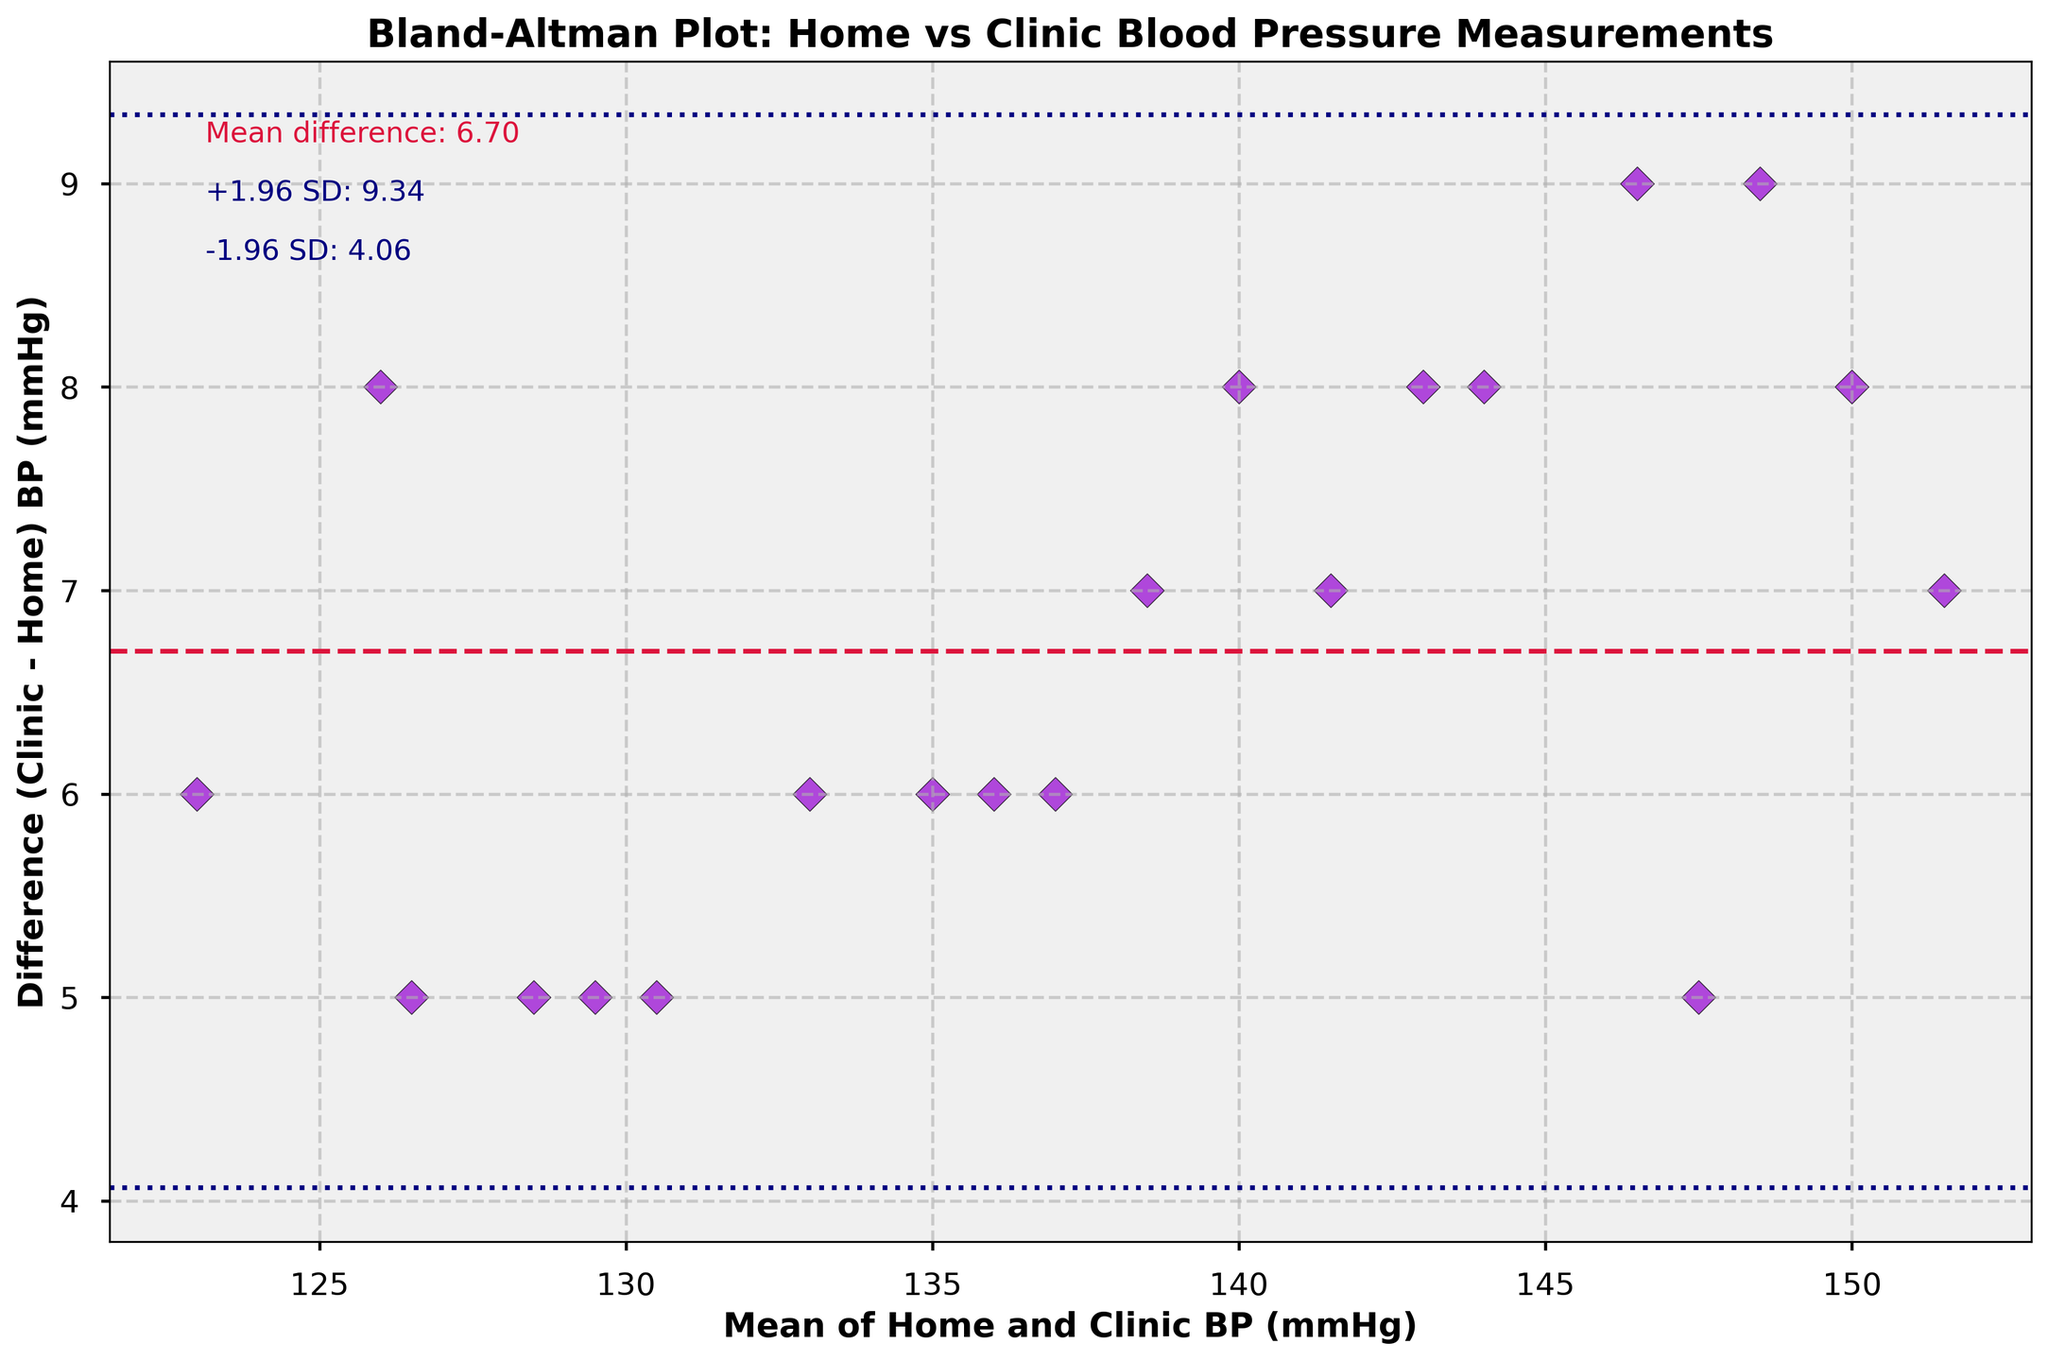What is the title of this plot? The title of the plot is displayed at the top and it indicates what the plot is about. In this case, it reads "Bland-Altman Plot: Home vs Clinic Blood Pressure Measurements".
Answer: Bland-Altman Plot: Home vs Clinic Blood Pressure Measurements How many data points are plotted in the figure? Count each marker (diamond) in the plot to determine the total number of data points. There are 20 markers.
Answer: 20 What does the x-axis represent in this plot? The x-axis label indicates it represents the "Mean of Home and Clinic BP (mmHg)", which is the average of the home and clinic blood pressure readings for each data point.
Answer: Mean of Home and Clinic BP (mmHg) What color and shape are the data points in the plot? Each data point is colored dark violet. They are diamond-shaped and outlined in black.
Answer: Dark violet diamonds outlined in black What is the mean difference between clinic and home measurements? The mean difference (or "md") is annotated on the plot. It is the value where the horizontal crimson dashed line is placed and noted as "Mean difference: 6.65".
Answer: 6.65 mmHg What is the approximate value of the upper limit of agreement? The upper limit of agreement is the mean difference plus 1.96 times the standard deviation, which is annotated as "+1.96 SD: 8.90" on the plot.
Answer: 8.90 mmHg What does the horizontal crimson dashed line represent? The horizontal crimson dashed line represents the mean difference between clinic and home measurements, visually indicated on the plot at the value 6.65 mmHg.
Answer: Mean difference between clinic and home measurements Are most of the differences positive or negative? By observing the position of most of the data points relative to the mean difference line, we can see that the majority of the points lie above the horizontal crimson dashed line, meaning the differences are mostly positive.
Answer: Positive How many data points exceed the upper limit of agreement? Count the number of points above the upper dashed navy line, which corresponds to the "+1.96 SD" limit. There are no data points above this line.
Answer: 0 What is the significance of the dashed navy lines? The dashed navy lines represent the limits of agreement, set at ±1.96 standard deviations from the mean difference. These lines encompass most of the data and indicate where most differences should lie if measurements are in agreement.
Answer: Limits of agreement (±1.96 standard deviations) 